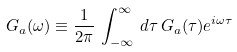<formula> <loc_0><loc_0><loc_500><loc_500>G _ { a } ( \omega ) \equiv \frac { 1 } { 2 \pi } \, \int _ { - \infty } ^ { \infty } \, d \tau \, G _ { a } ( \tau ) e ^ { i \omega \tau }</formula> 